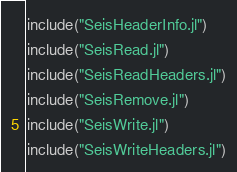<code> <loc_0><loc_0><loc_500><loc_500><_Julia_>include("SeisHeaderInfo.jl")
include("SeisRead.jl")
include("SeisReadHeaders.jl")
include("SeisRemove.jl")
include("SeisWrite.jl")
include("SeisWriteHeaders.jl")
</code> 